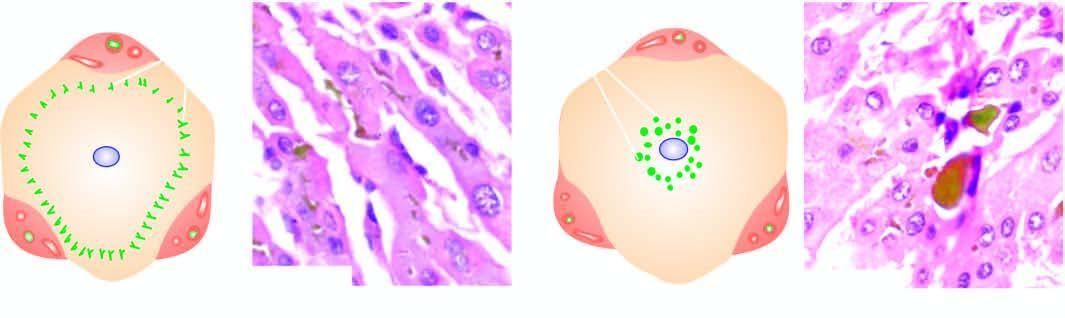what is characterised by elongated bile plugs in the canaliculi of hepatocytes at the periphery of the lobule?
Answer the question using a single word or phrase. Intrahepatic cholestasis 